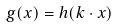<formula> <loc_0><loc_0><loc_500><loc_500>g ( x ) = h ( k \cdot x )</formula> 